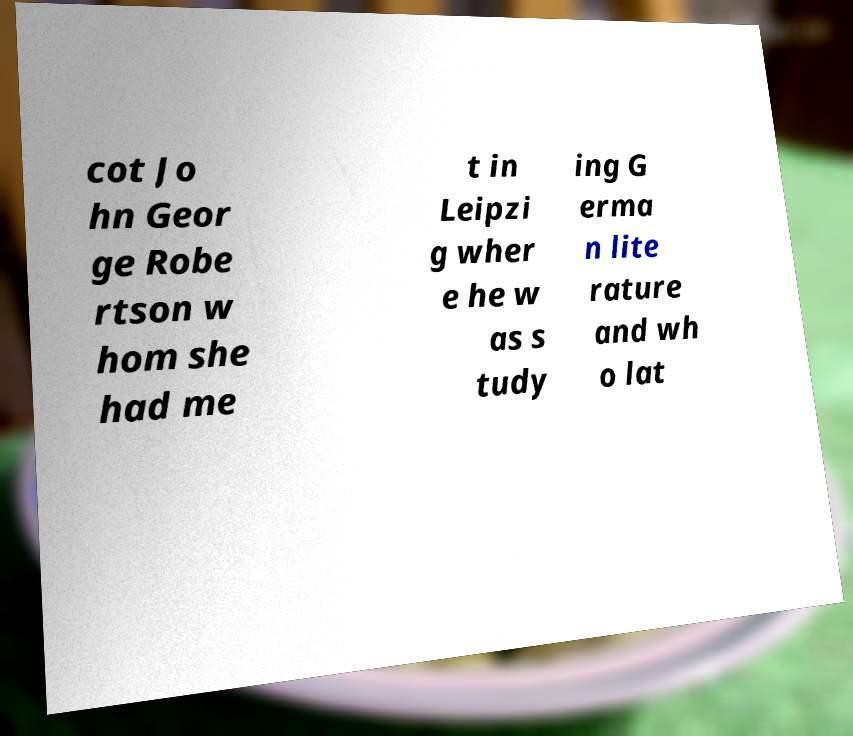Please identify and transcribe the text found in this image. cot Jo hn Geor ge Robe rtson w hom she had me t in Leipzi g wher e he w as s tudy ing G erma n lite rature and wh o lat 